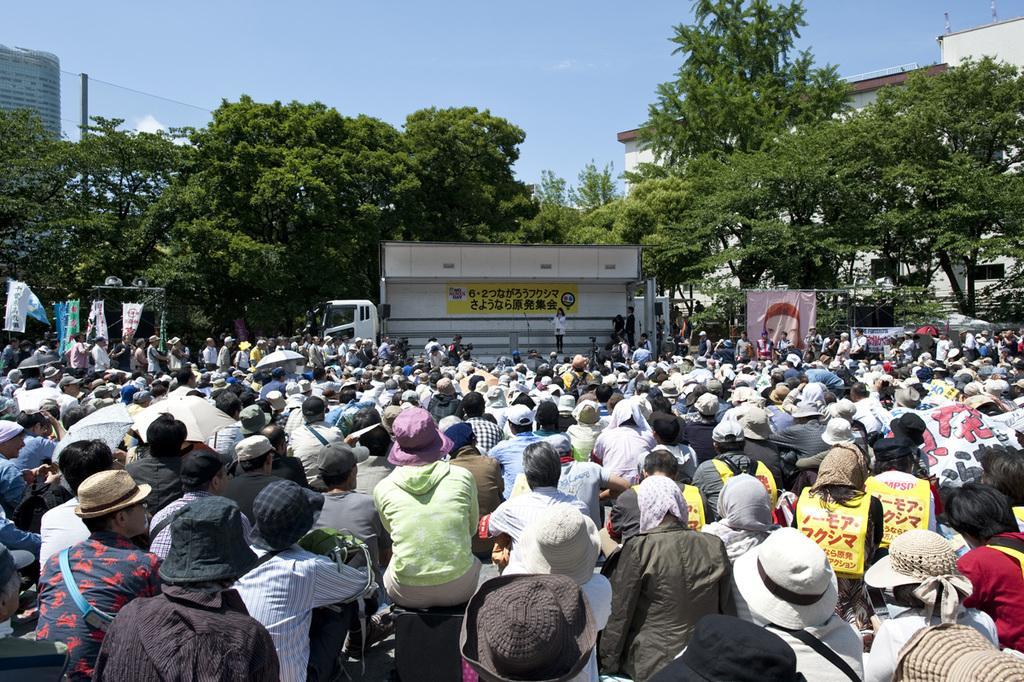Could you give a brief overview of what you see in this image? In this image, from left to right people are sitting and at the back there are some trees and the background is the sky. 